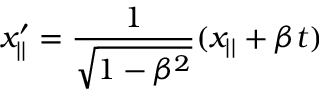Convert formula to latex. <formula><loc_0><loc_0><loc_500><loc_500>x _ { | | } ^ { \prime } = \frac { 1 } { \sqrt { 1 - \beta ^ { 2 } } } ( x _ { | | } + \beta t )</formula> 